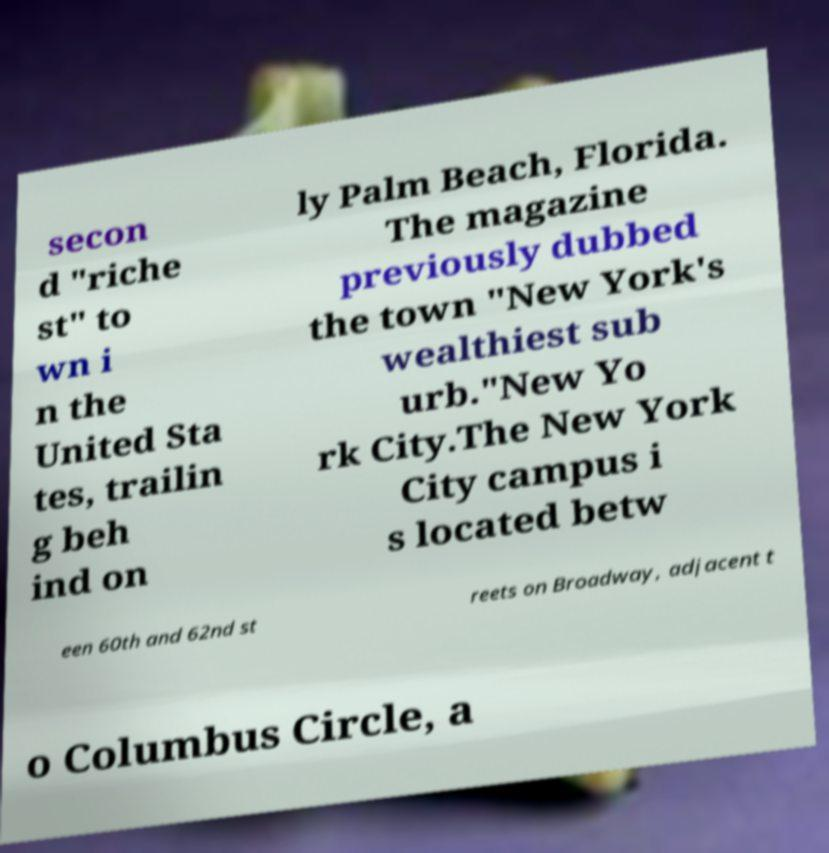Could you extract and type out the text from this image? secon d "riche st" to wn i n the United Sta tes, trailin g beh ind on ly Palm Beach, Florida. The magazine previously dubbed the town "New York's wealthiest sub urb."New Yo rk City.The New York City campus i s located betw een 60th and 62nd st reets on Broadway, adjacent t o Columbus Circle, a 